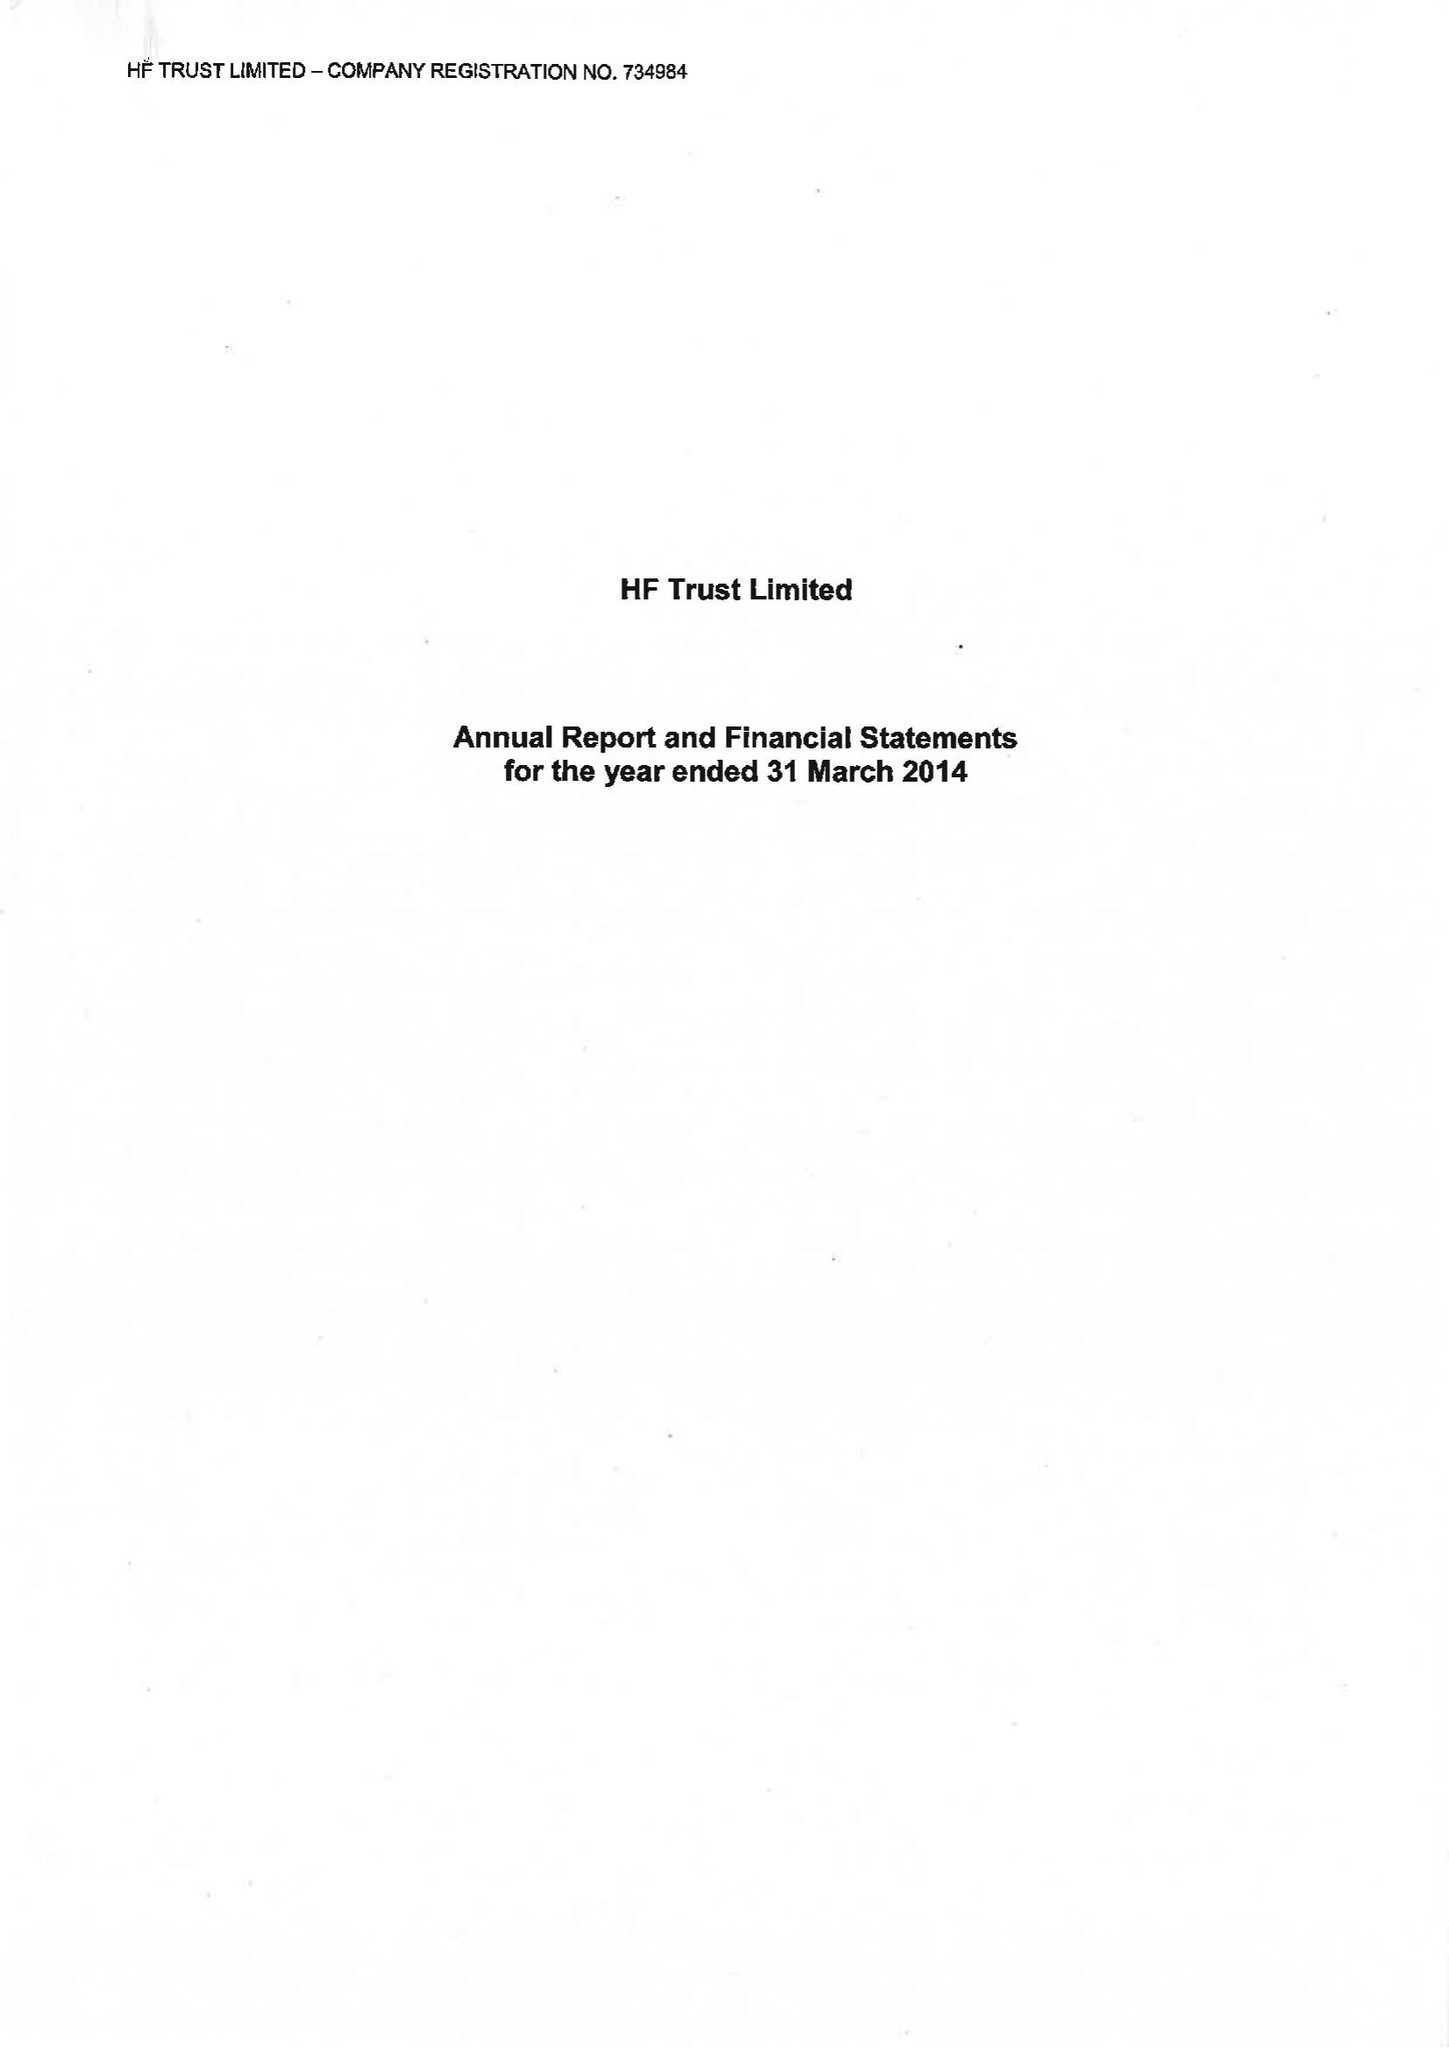What is the value for the address__post_town?
Answer the question using a single word or phrase. BRISTOL 